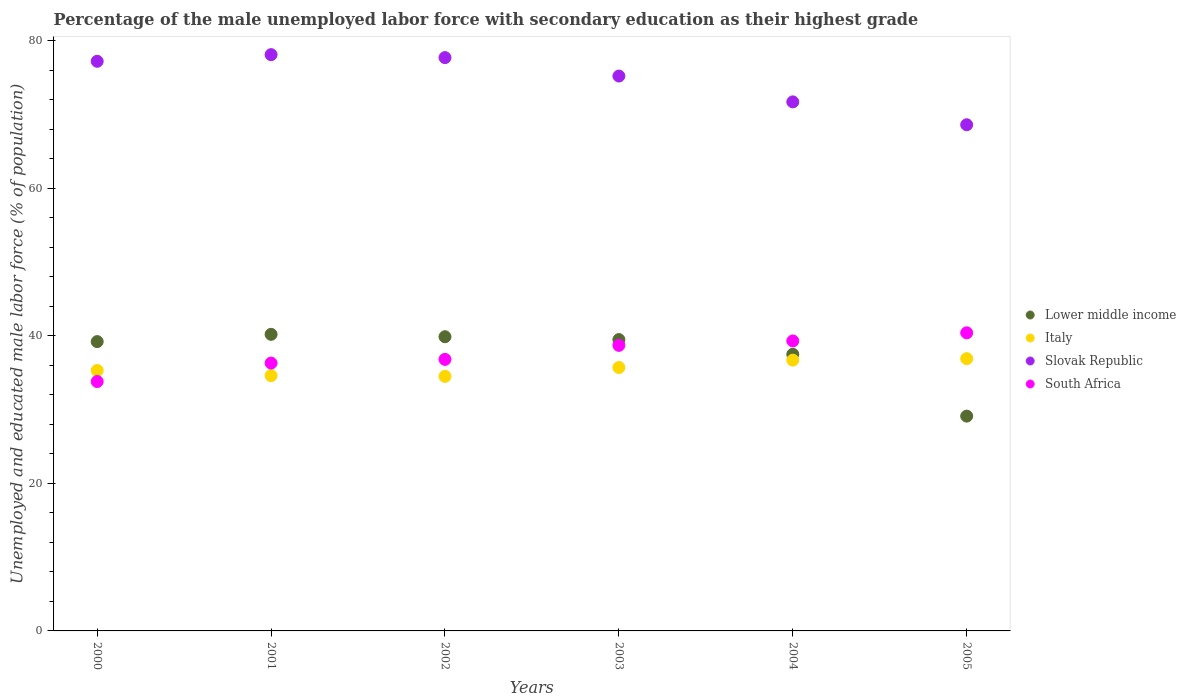How many different coloured dotlines are there?
Ensure brevity in your answer.  4. Is the number of dotlines equal to the number of legend labels?
Provide a succinct answer. Yes. What is the percentage of the unemployed male labor force with secondary education in Slovak Republic in 2002?
Offer a very short reply. 77.7. Across all years, what is the maximum percentage of the unemployed male labor force with secondary education in Slovak Republic?
Provide a short and direct response. 78.1. Across all years, what is the minimum percentage of the unemployed male labor force with secondary education in Italy?
Your response must be concise. 34.5. In which year was the percentage of the unemployed male labor force with secondary education in South Africa minimum?
Ensure brevity in your answer.  2000. What is the total percentage of the unemployed male labor force with secondary education in South Africa in the graph?
Provide a succinct answer. 225.3. What is the difference between the percentage of the unemployed male labor force with secondary education in Slovak Republic in 2004 and that in 2005?
Offer a very short reply. 3.1. What is the difference between the percentage of the unemployed male labor force with secondary education in Italy in 2004 and the percentage of the unemployed male labor force with secondary education in Slovak Republic in 2003?
Keep it short and to the point. -38.5. What is the average percentage of the unemployed male labor force with secondary education in Lower middle income per year?
Ensure brevity in your answer.  37.56. In the year 2004, what is the difference between the percentage of the unemployed male labor force with secondary education in Slovak Republic and percentage of the unemployed male labor force with secondary education in South Africa?
Ensure brevity in your answer.  32.4. What is the ratio of the percentage of the unemployed male labor force with secondary education in Italy in 2002 to that in 2003?
Offer a terse response. 0.97. Is the difference between the percentage of the unemployed male labor force with secondary education in Slovak Republic in 2002 and 2004 greater than the difference between the percentage of the unemployed male labor force with secondary education in South Africa in 2002 and 2004?
Make the answer very short. Yes. What is the difference between the highest and the second highest percentage of the unemployed male labor force with secondary education in Slovak Republic?
Offer a very short reply. 0.4. What is the difference between the highest and the lowest percentage of the unemployed male labor force with secondary education in Italy?
Offer a terse response. 2.4. In how many years, is the percentage of the unemployed male labor force with secondary education in South Africa greater than the average percentage of the unemployed male labor force with secondary education in South Africa taken over all years?
Make the answer very short. 3. Is it the case that in every year, the sum of the percentage of the unemployed male labor force with secondary education in Italy and percentage of the unemployed male labor force with secondary education in Lower middle income  is greater than the sum of percentage of the unemployed male labor force with secondary education in South Africa and percentage of the unemployed male labor force with secondary education in Slovak Republic?
Provide a succinct answer. No. Is it the case that in every year, the sum of the percentage of the unemployed male labor force with secondary education in South Africa and percentage of the unemployed male labor force with secondary education in Italy  is greater than the percentage of the unemployed male labor force with secondary education in Lower middle income?
Your answer should be compact. Yes. Is the percentage of the unemployed male labor force with secondary education in Italy strictly greater than the percentage of the unemployed male labor force with secondary education in Slovak Republic over the years?
Your response must be concise. No. Is the percentage of the unemployed male labor force with secondary education in Slovak Republic strictly less than the percentage of the unemployed male labor force with secondary education in Lower middle income over the years?
Your response must be concise. No. What is the difference between two consecutive major ticks on the Y-axis?
Give a very brief answer. 20. Are the values on the major ticks of Y-axis written in scientific E-notation?
Ensure brevity in your answer.  No. Does the graph contain grids?
Your answer should be compact. No. Where does the legend appear in the graph?
Your answer should be very brief. Center right. What is the title of the graph?
Give a very brief answer. Percentage of the male unemployed labor force with secondary education as their highest grade. What is the label or title of the Y-axis?
Ensure brevity in your answer.  Unemployed and educated male labor force (% of population). What is the Unemployed and educated male labor force (% of population) of Lower middle income in 2000?
Make the answer very short. 39.21. What is the Unemployed and educated male labor force (% of population) of Italy in 2000?
Your answer should be compact. 35.3. What is the Unemployed and educated male labor force (% of population) in Slovak Republic in 2000?
Offer a terse response. 77.2. What is the Unemployed and educated male labor force (% of population) in South Africa in 2000?
Provide a succinct answer. 33.8. What is the Unemployed and educated male labor force (% of population) in Lower middle income in 2001?
Ensure brevity in your answer.  40.19. What is the Unemployed and educated male labor force (% of population) in Italy in 2001?
Your answer should be compact. 34.6. What is the Unemployed and educated male labor force (% of population) of Slovak Republic in 2001?
Offer a very short reply. 78.1. What is the Unemployed and educated male labor force (% of population) in South Africa in 2001?
Make the answer very short. 36.3. What is the Unemployed and educated male labor force (% of population) of Lower middle income in 2002?
Provide a succinct answer. 39.87. What is the Unemployed and educated male labor force (% of population) of Italy in 2002?
Offer a terse response. 34.5. What is the Unemployed and educated male labor force (% of population) in Slovak Republic in 2002?
Ensure brevity in your answer.  77.7. What is the Unemployed and educated male labor force (% of population) of South Africa in 2002?
Offer a very short reply. 36.8. What is the Unemployed and educated male labor force (% of population) of Lower middle income in 2003?
Make the answer very short. 39.49. What is the Unemployed and educated male labor force (% of population) in Italy in 2003?
Provide a succinct answer. 35.7. What is the Unemployed and educated male labor force (% of population) of Slovak Republic in 2003?
Ensure brevity in your answer.  75.2. What is the Unemployed and educated male labor force (% of population) in South Africa in 2003?
Keep it short and to the point. 38.7. What is the Unemployed and educated male labor force (% of population) in Lower middle income in 2004?
Ensure brevity in your answer.  37.49. What is the Unemployed and educated male labor force (% of population) of Italy in 2004?
Make the answer very short. 36.7. What is the Unemployed and educated male labor force (% of population) of Slovak Republic in 2004?
Your response must be concise. 71.7. What is the Unemployed and educated male labor force (% of population) in South Africa in 2004?
Ensure brevity in your answer.  39.3. What is the Unemployed and educated male labor force (% of population) in Lower middle income in 2005?
Make the answer very short. 29.11. What is the Unemployed and educated male labor force (% of population) in Italy in 2005?
Keep it short and to the point. 36.9. What is the Unemployed and educated male labor force (% of population) of Slovak Republic in 2005?
Offer a very short reply. 68.6. What is the Unemployed and educated male labor force (% of population) in South Africa in 2005?
Provide a short and direct response. 40.4. Across all years, what is the maximum Unemployed and educated male labor force (% of population) in Lower middle income?
Offer a very short reply. 40.19. Across all years, what is the maximum Unemployed and educated male labor force (% of population) in Italy?
Your answer should be compact. 36.9. Across all years, what is the maximum Unemployed and educated male labor force (% of population) in Slovak Republic?
Your response must be concise. 78.1. Across all years, what is the maximum Unemployed and educated male labor force (% of population) in South Africa?
Ensure brevity in your answer.  40.4. Across all years, what is the minimum Unemployed and educated male labor force (% of population) in Lower middle income?
Your answer should be compact. 29.11. Across all years, what is the minimum Unemployed and educated male labor force (% of population) in Italy?
Your response must be concise. 34.5. Across all years, what is the minimum Unemployed and educated male labor force (% of population) of Slovak Republic?
Offer a very short reply. 68.6. Across all years, what is the minimum Unemployed and educated male labor force (% of population) of South Africa?
Provide a short and direct response. 33.8. What is the total Unemployed and educated male labor force (% of population) of Lower middle income in the graph?
Provide a succinct answer. 225.36. What is the total Unemployed and educated male labor force (% of population) in Italy in the graph?
Offer a very short reply. 213.7. What is the total Unemployed and educated male labor force (% of population) in Slovak Republic in the graph?
Offer a terse response. 448.5. What is the total Unemployed and educated male labor force (% of population) of South Africa in the graph?
Ensure brevity in your answer.  225.3. What is the difference between the Unemployed and educated male labor force (% of population) of Lower middle income in 2000 and that in 2001?
Your answer should be compact. -0.98. What is the difference between the Unemployed and educated male labor force (% of population) in Lower middle income in 2000 and that in 2002?
Provide a short and direct response. -0.66. What is the difference between the Unemployed and educated male labor force (% of population) in South Africa in 2000 and that in 2002?
Provide a short and direct response. -3. What is the difference between the Unemployed and educated male labor force (% of population) of Lower middle income in 2000 and that in 2003?
Provide a succinct answer. -0.28. What is the difference between the Unemployed and educated male labor force (% of population) of Italy in 2000 and that in 2003?
Your response must be concise. -0.4. What is the difference between the Unemployed and educated male labor force (% of population) of Slovak Republic in 2000 and that in 2003?
Offer a terse response. 2. What is the difference between the Unemployed and educated male labor force (% of population) in Lower middle income in 2000 and that in 2004?
Provide a short and direct response. 1.72. What is the difference between the Unemployed and educated male labor force (% of population) of South Africa in 2000 and that in 2004?
Your response must be concise. -5.5. What is the difference between the Unemployed and educated male labor force (% of population) in Lower middle income in 2000 and that in 2005?
Ensure brevity in your answer.  10.1. What is the difference between the Unemployed and educated male labor force (% of population) in Italy in 2000 and that in 2005?
Keep it short and to the point. -1.6. What is the difference between the Unemployed and educated male labor force (% of population) of South Africa in 2000 and that in 2005?
Make the answer very short. -6.6. What is the difference between the Unemployed and educated male labor force (% of population) in Lower middle income in 2001 and that in 2002?
Your answer should be compact. 0.32. What is the difference between the Unemployed and educated male labor force (% of population) of Italy in 2001 and that in 2002?
Your answer should be very brief. 0.1. What is the difference between the Unemployed and educated male labor force (% of population) in Slovak Republic in 2001 and that in 2002?
Your answer should be compact. 0.4. What is the difference between the Unemployed and educated male labor force (% of population) of South Africa in 2001 and that in 2002?
Provide a short and direct response. -0.5. What is the difference between the Unemployed and educated male labor force (% of population) of Lower middle income in 2001 and that in 2003?
Keep it short and to the point. 0.71. What is the difference between the Unemployed and educated male labor force (% of population) in Slovak Republic in 2001 and that in 2003?
Give a very brief answer. 2.9. What is the difference between the Unemployed and educated male labor force (% of population) in Lower middle income in 2001 and that in 2004?
Your answer should be very brief. 2.71. What is the difference between the Unemployed and educated male labor force (% of population) in Slovak Republic in 2001 and that in 2004?
Keep it short and to the point. 6.4. What is the difference between the Unemployed and educated male labor force (% of population) in Lower middle income in 2001 and that in 2005?
Make the answer very short. 11.08. What is the difference between the Unemployed and educated male labor force (% of population) in Slovak Republic in 2001 and that in 2005?
Keep it short and to the point. 9.5. What is the difference between the Unemployed and educated male labor force (% of population) of South Africa in 2001 and that in 2005?
Offer a very short reply. -4.1. What is the difference between the Unemployed and educated male labor force (% of population) in Lower middle income in 2002 and that in 2003?
Provide a succinct answer. 0.39. What is the difference between the Unemployed and educated male labor force (% of population) of Lower middle income in 2002 and that in 2004?
Your answer should be compact. 2.38. What is the difference between the Unemployed and educated male labor force (% of population) of Slovak Republic in 2002 and that in 2004?
Offer a terse response. 6. What is the difference between the Unemployed and educated male labor force (% of population) in Lower middle income in 2002 and that in 2005?
Make the answer very short. 10.76. What is the difference between the Unemployed and educated male labor force (% of population) in Italy in 2002 and that in 2005?
Provide a short and direct response. -2.4. What is the difference between the Unemployed and educated male labor force (% of population) of Slovak Republic in 2002 and that in 2005?
Your response must be concise. 9.1. What is the difference between the Unemployed and educated male labor force (% of population) of Lower middle income in 2003 and that in 2004?
Offer a very short reply. 2. What is the difference between the Unemployed and educated male labor force (% of population) in Lower middle income in 2003 and that in 2005?
Your answer should be very brief. 10.37. What is the difference between the Unemployed and educated male labor force (% of population) of Italy in 2003 and that in 2005?
Make the answer very short. -1.2. What is the difference between the Unemployed and educated male labor force (% of population) in Slovak Republic in 2003 and that in 2005?
Offer a terse response. 6.6. What is the difference between the Unemployed and educated male labor force (% of population) of South Africa in 2003 and that in 2005?
Provide a succinct answer. -1.7. What is the difference between the Unemployed and educated male labor force (% of population) of Lower middle income in 2004 and that in 2005?
Provide a succinct answer. 8.38. What is the difference between the Unemployed and educated male labor force (% of population) of Italy in 2004 and that in 2005?
Keep it short and to the point. -0.2. What is the difference between the Unemployed and educated male labor force (% of population) of Slovak Republic in 2004 and that in 2005?
Offer a terse response. 3.1. What is the difference between the Unemployed and educated male labor force (% of population) of Lower middle income in 2000 and the Unemployed and educated male labor force (% of population) of Italy in 2001?
Offer a terse response. 4.61. What is the difference between the Unemployed and educated male labor force (% of population) of Lower middle income in 2000 and the Unemployed and educated male labor force (% of population) of Slovak Republic in 2001?
Your answer should be very brief. -38.89. What is the difference between the Unemployed and educated male labor force (% of population) in Lower middle income in 2000 and the Unemployed and educated male labor force (% of population) in South Africa in 2001?
Your answer should be very brief. 2.91. What is the difference between the Unemployed and educated male labor force (% of population) in Italy in 2000 and the Unemployed and educated male labor force (% of population) in Slovak Republic in 2001?
Provide a succinct answer. -42.8. What is the difference between the Unemployed and educated male labor force (% of population) in Slovak Republic in 2000 and the Unemployed and educated male labor force (% of population) in South Africa in 2001?
Make the answer very short. 40.9. What is the difference between the Unemployed and educated male labor force (% of population) in Lower middle income in 2000 and the Unemployed and educated male labor force (% of population) in Italy in 2002?
Ensure brevity in your answer.  4.71. What is the difference between the Unemployed and educated male labor force (% of population) of Lower middle income in 2000 and the Unemployed and educated male labor force (% of population) of Slovak Republic in 2002?
Offer a very short reply. -38.49. What is the difference between the Unemployed and educated male labor force (% of population) of Lower middle income in 2000 and the Unemployed and educated male labor force (% of population) of South Africa in 2002?
Provide a short and direct response. 2.41. What is the difference between the Unemployed and educated male labor force (% of population) in Italy in 2000 and the Unemployed and educated male labor force (% of population) in Slovak Republic in 2002?
Provide a short and direct response. -42.4. What is the difference between the Unemployed and educated male labor force (% of population) of Slovak Republic in 2000 and the Unemployed and educated male labor force (% of population) of South Africa in 2002?
Make the answer very short. 40.4. What is the difference between the Unemployed and educated male labor force (% of population) of Lower middle income in 2000 and the Unemployed and educated male labor force (% of population) of Italy in 2003?
Provide a succinct answer. 3.51. What is the difference between the Unemployed and educated male labor force (% of population) of Lower middle income in 2000 and the Unemployed and educated male labor force (% of population) of Slovak Republic in 2003?
Offer a terse response. -35.99. What is the difference between the Unemployed and educated male labor force (% of population) in Lower middle income in 2000 and the Unemployed and educated male labor force (% of population) in South Africa in 2003?
Make the answer very short. 0.51. What is the difference between the Unemployed and educated male labor force (% of population) of Italy in 2000 and the Unemployed and educated male labor force (% of population) of Slovak Republic in 2003?
Offer a very short reply. -39.9. What is the difference between the Unemployed and educated male labor force (% of population) of Italy in 2000 and the Unemployed and educated male labor force (% of population) of South Africa in 2003?
Keep it short and to the point. -3.4. What is the difference between the Unemployed and educated male labor force (% of population) in Slovak Republic in 2000 and the Unemployed and educated male labor force (% of population) in South Africa in 2003?
Your response must be concise. 38.5. What is the difference between the Unemployed and educated male labor force (% of population) in Lower middle income in 2000 and the Unemployed and educated male labor force (% of population) in Italy in 2004?
Offer a very short reply. 2.51. What is the difference between the Unemployed and educated male labor force (% of population) of Lower middle income in 2000 and the Unemployed and educated male labor force (% of population) of Slovak Republic in 2004?
Your answer should be very brief. -32.49. What is the difference between the Unemployed and educated male labor force (% of population) of Lower middle income in 2000 and the Unemployed and educated male labor force (% of population) of South Africa in 2004?
Provide a short and direct response. -0.09. What is the difference between the Unemployed and educated male labor force (% of population) of Italy in 2000 and the Unemployed and educated male labor force (% of population) of Slovak Republic in 2004?
Your response must be concise. -36.4. What is the difference between the Unemployed and educated male labor force (% of population) in Italy in 2000 and the Unemployed and educated male labor force (% of population) in South Africa in 2004?
Keep it short and to the point. -4. What is the difference between the Unemployed and educated male labor force (% of population) in Slovak Republic in 2000 and the Unemployed and educated male labor force (% of population) in South Africa in 2004?
Provide a short and direct response. 37.9. What is the difference between the Unemployed and educated male labor force (% of population) in Lower middle income in 2000 and the Unemployed and educated male labor force (% of population) in Italy in 2005?
Make the answer very short. 2.31. What is the difference between the Unemployed and educated male labor force (% of population) of Lower middle income in 2000 and the Unemployed and educated male labor force (% of population) of Slovak Republic in 2005?
Provide a succinct answer. -29.39. What is the difference between the Unemployed and educated male labor force (% of population) of Lower middle income in 2000 and the Unemployed and educated male labor force (% of population) of South Africa in 2005?
Offer a very short reply. -1.19. What is the difference between the Unemployed and educated male labor force (% of population) of Italy in 2000 and the Unemployed and educated male labor force (% of population) of Slovak Republic in 2005?
Offer a very short reply. -33.3. What is the difference between the Unemployed and educated male labor force (% of population) in Italy in 2000 and the Unemployed and educated male labor force (% of population) in South Africa in 2005?
Offer a terse response. -5.1. What is the difference between the Unemployed and educated male labor force (% of population) in Slovak Republic in 2000 and the Unemployed and educated male labor force (% of population) in South Africa in 2005?
Your response must be concise. 36.8. What is the difference between the Unemployed and educated male labor force (% of population) of Lower middle income in 2001 and the Unemployed and educated male labor force (% of population) of Italy in 2002?
Ensure brevity in your answer.  5.69. What is the difference between the Unemployed and educated male labor force (% of population) in Lower middle income in 2001 and the Unemployed and educated male labor force (% of population) in Slovak Republic in 2002?
Your response must be concise. -37.51. What is the difference between the Unemployed and educated male labor force (% of population) of Lower middle income in 2001 and the Unemployed and educated male labor force (% of population) of South Africa in 2002?
Offer a very short reply. 3.39. What is the difference between the Unemployed and educated male labor force (% of population) of Italy in 2001 and the Unemployed and educated male labor force (% of population) of Slovak Republic in 2002?
Your response must be concise. -43.1. What is the difference between the Unemployed and educated male labor force (% of population) in Slovak Republic in 2001 and the Unemployed and educated male labor force (% of population) in South Africa in 2002?
Make the answer very short. 41.3. What is the difference between the Unemployed and educated male labor force (% of population) of Lower middle income in 2001 and the Unemployed and educated male labor force (% of population) of Italy in 2003?
Your answer should be compact. 4.49. What is the difference between the Unemployed and educated male labor force (% of population) of Lower middle income in 2001 and the Unemployed and educated male labor force (% of population) of Slovak Republic in 2003?
Offer a terse response. -35.01. What is the difference between the Unemployed and educated male labor force (% of population) of Lower middle income in 2001 and the Unemployed and educated male labor force (% of population) of South Africa in 2003?
Ensure brevity in your answer.  1.49. What is the difference between the Unemployed and educated male labor force (% of population) of Italy in 2001 and the Unemployed and educated male labor force (% of population) of Slovak Republic in 2003?
Provide a succinct answer. -40.6. What is the difference between the Unemployed and educated male labor force (% of population) of Italy in 2001 and the Unemployed and educated male labor force (% of population) of South Africa in 2003?
Provide a short and direct response. -4.1. What is the difference between the Unemployed and educated male labor force (% of population) in Slovak Republic in 2001 and the Unemployed and educated male labor force (% of population) in South Africa in 2003?
Provide a short and direct response. 39.4. What is the difference between the Unemployed and educated male labor force (% of population) in Lower middle income in 2001 and the Unemployed and educated male labor force (% of population) in Italy in 2004?
Keep it short and to the point. 3.49. What is the difference between the Unemployed and educated male labor force (% of population) of Lower middle income in 2001 and the Unemployed and educated male labor force (% of population) of Slovak Republic in 2004?
Your answer should be compact. -31.51. What is the difference between the Unemployed and educated male labor force (% of population) in Lower middle income in 2001 and the Unemployed and educated male labor force (% of population) in South Africa in 2004?
Ensure brevity in your answer.  0.89. What is the difference between the Unemployed and educated male labor force (% of population) of Italy in 2001 and the Unemployed and educated male labor force (% of population) of Slovak Republic in 2004?
Ensure brevity in your answer.  -37.1. What is the difference between the Unemployed and educated male labor force (% of population) in Italy in 2001 and the Unemployed and educated male labor force (% of population) in South Africa in 2004?
Your answer should be compact. -4.7. What is the difference between the Unemployed and educated male labor force (% of population) in Slovak Republic in 2001 and the Unemployed and educated male labor force (% of population) in South Africa in 2004?
Your answer should be compact. 38.8. What is the difference between the Unemployed and educated male labor force (% of population) of Lower middle income in 2001 and the Unemployed and educated male labor force (% of population) of Italy in 2005?
Offer a terse response. 3.29. What is the difference between the Unemployed and educated male labor force (% of population) of Lower middle income in 2001 and the Unemployed and educated male labor force (% of population) of Slovak Republic in 2005?
Provide a short and direct response. -28.41. What is the difference between the Unemployed and educated male labor force (% of population) of Lower middle income in 2001 and the Unemployed and educated male labor force (% of population) of South Africa in 2005?
Your answer should be very brief. -0.21. What is the difference between the Unemployed and educated male labor force (% of population) in Italy in 2001 and the Unemployed and educated male labor force (% of population) in Slovak Republic in 2005?
Your answer should be very brief. -34. What is the difference between the Unemployed and educated male labor force (% of population) in Slovak Republic in 2001 and the Unemployed and educated male labor force (% of population) in South Africa in 2005?
Your answer should be very brief. 37.7. What is the difference between the Unemployed and educated male labor force (% of population) of Lower middle income in 2002 and the Unemployed and educated male labor force (% of population) of Italy in 2003?
Provide a succinct answer. 4.17. What is the difference between the Unemployed and educated male labor force (% of population) in Lower middle income in 2002 and the Unemployed and educated male labor force (% of population) in Slovak Republic in 2003?
Your response must be concise. -35.33. What is the difference between the Unemployed and educated male labor force (% of population) in Lower middle income in 2002 and the Unemployed and educated male labor force (% of population) in South Africa in 2003?
Make the answer very short. 1.17. What is the difference between the Unemployed and educated male labor force (% of population) of Italy in 2002 and the Unemployed and educated male labor force (% of population) of Slovak Republic in 2003?
Offer a terse response. -40.7. What is the difference between the Unemployed and educated male labor force (% of population) in Italy in 2002 and the Unemployed and educated male labor force (% of population) in South Africa in 2003?
Provide a succinct answer. -4.2. What is the difference between the Unemployed and educated male labor force (% of population) of Slovak Republic in 2002 and the Unemployed and educated male labor force (% of population) of South Africa in 2003?
Make the answer very short. 39. What is the difference between the Unemployed and educated male labor force (% of population) of Lower middle income in 2002 and the Unemployed and educated male labor force (% of population) of Italy in 2004?
Ensure brevity in your answer.  3.17. What is the difference between the Unemployed and educated male labor force (% of population) in Lower middle income in 2002 and the Unemployed and educated male labor force (% of population) in Slovak Republic in 2004?
Keep it short and to the point. -31.83. What is the difference between the Unemployed and educated male labor force (% of population) in Lower middle income in 2002 and the Unemployed and educated male labor force (% of population) in South Africa in 2004?
Your response must be concise. 0.57. What is the difference between the Unemployed and educated male labor force (% of population) in Italy in 2002 and the Unemployed and educated male labor force (% of population) in Slovak Republic in 2004?
Your answer should be compact. -37.2. What is the difference between the Unemployed and educated male labor force (% of population) of Slovak Republic in 2002 and the Unemployed and educated male labor force (% of population) of South Africa in 2004?
Offer a very short reply. 38.4. What is the difference between the Unemployed and educated male labor force (% of population) of Lower middle income in 2002 and the Unemployed and educated male labor force (% of population) of Italy in 2005?
Make the answer very short. 2.97. What is the difference between the Unemployed and educated male labor force (% of population) in Lower middle income in 2002 and the Unemployed and educated male labor force (% of population) in Slovak Republic in 2005?
Give a very brief answer. -28.73. What is the difference between the Unemployed and educated male labor force (% of population) of Lower middle income in 2002 and the Unemployed and educated male labor force (% of population) of South Africa in 2005?
Offer a terse response. -0.53. What is the difference between the Unemployed and educated male labor force (% of population) of Italy in 2002 and the Unemployed and educated male labor force (% of population) of Slovak Republic in 2005?
Keep it short and to the point. -34.1. What is the difference between the Unemployed and educated male labor force (% of population) in Italy in 2002 and the Unemployed and educated male labor force (% of population) in South Africa in 2005?
Your answer should be very brief. -5.9. What is the difference between the Unemployed and educated male labor force (% of population) in Slovak Republic in 2002 and the Unemployed and educated male labor force (% of population) in South Africa in 2005?
Keep it short and to the point. 37.3. What is the difference between the Unemployed and educated male labor force (% of population) of Lower middle income in 2003 and the Unemployed and educated male labor force (% of population) of Italy in 2004?
Your answer should be very brief. 2.79. What is the difference between the Unemployed and educated male labor force (% of population) of Lower middle income in 2003 and the Unemployed and educated male labor force (% of population) of Slovak Republic in 2004?
Ensure brevity in your answer.  -32.22. What is the difference between the Unemployed and educated male labor force (% of population) of Lower middle income in 2003 and the Unemployed and educated male labor force (% of population) of South Africa in 2004?
Offer a terse response. 0.18. What is the difference between the Unemployed and educated male labor force (% of population) in Italy in 2003 and the Unemployed and educated male labor force (% of population) in Slovak Republic in 2004?
Provide a succinct answer. -36. What is the difference between the Unemployed and educated male labor force (% of population) in Slovak Republic in 2003 and the Unemployed and educated male labor force (% of population) in South Africa in 2004?
Provide a succinct answer. 35.9. What is the difference between the Unemployed and educated male labor force (% of population) in Lower middle income in 2003 and the Unemployed and educated male labor force (% of population) in Italy in 2005?
Offer a very short reply. 2.58. What is the difference between the Unemployed and educated male labor force (% of population) of Lower middle income in 2003 and the Unemployed and educated male labor force (% of population) of Slovak Republic in 2005?
Your answer should be very brief. -29.11. What is the difference between the Unemployed and educated male labor force (% of population) of Lower middle income in 2003 and the Unemployed and educated male labor force (% of population) of South Africa in 2005?
Offer a very short reply. -0.92. What is the difference between the Unemployed and educated male labor force (% of population) in Italy in 2003 and the Unemployed and educated male labor force (% of population) in Slovak Republic in 2005?
Keep it short and to the point. -32.9. What is the difference between the Unemployed and educated male labor force (% of population) in Slovak Republic in 2003 and the Unemployed and educated male labor force (% of population) in South Africa in 2005?
Provide a short and direct response. 34.8. What is the difference between the Unemployed and educated male labor force (% of population) in Lower middle income in 2004 and the Unemployed and educated male labor force (% of population) in Italy in 2005?
Your answer should be very brief. 0.59. What is the difference between the Unemployed and educated male labor force (% of population) of Lower middle income in 2004 and the Unemployed and educated male labor force (% of population) of Slovak Republic in 2005?
Keep it short and to the point. -31.11. What is the difference between the Unemployed and educated male labor force (% of population) of Lower middle income in 2004 and the Unemployed and educated male labor force (% of population) of South Africa in 2005?
Offer a terse response. -2.91. What is the difference between the Unemployed and educated male labor force (% of population) of Italy in 2004 and the Unemployed and educated male labor force (% of population) of Slovak Republic in 2005?
Give a very brief answer. -31.9. What is the difference between the Unemployed and educated male labor force (% of population) of Slovak Republic in 2004 and the Unemployed and educated male labor force (% of population) of South Africa in 2005?
Your answer should be very brief. 31.3. What is the average Unemployed and educated male labor force (% of population) in Lower middle income per year?
Provide a succinct answer. 37.56. What is the average Unemployed and educated male labor force (% of population) in Italy per year?
Offer a very short reply. 35.62. What is the average Unemployed and educated male labor force (% of population) in Slovak Republic per year?
Offer a terse response. 74.75. What is the average Unemployed and educated male labor force (% of population) in South Africa per year?
Offer a very short reply. 37.55. In the year 2000, what is the difference between the Unemployed and educated male labor force (% of population) in Lower middle income and Unemployed and educated male labor force (% of population) in Italy?
Your answer should be very brief. 3.91. In the year 2000, what is the difference between the Unemployed and educated male labor force (% of population) in Lower middle income and Unemployed and educated male labor force (% of population) in Slovak Republic?
Keep it short and to the point. -37.99. In the year 2000, what is the difference between the Unemployed and educated male labor force (% of population) in Lower middle income and Unemployed and educated male labor force (% of population) in South Africa?
Your answer should be very brief. 5.41. In the year 2000, what is the difference between the Unemployed and educated male labor force (% of population) in Italy and Unemployed and educated male labor force (% of population) in Slovak Republic?
Offer a terse response. -41.9. In the year 2000, what is the difference between the Unemployed and educated male labor force (% of population) of Italy and Unemployed and educated male labor force (% of population) of South Africa?
Your answer should be very brief. 1.5. In the year 2000, what is the difference between the Unemployed and educated male labor force (% of population) of Slovak Republic and Unemployed and educated male labor force (% of population) of South Africa?
Provide a succinct answer. 43.4. In the year 2001, what is the difference between the Unemployed and educated male labor force (% of population) of Lower middle income and Unemployed and educated male labor force (% of population) of Italy?
Keep it short and to the point. 5.59. In the year 2001, what is the difference between the Unemployed and educated male labor force (% of population) in Lower middle income and Unemployed and educated male labor force (% of population) in Slovak Republic?
Offer a very short reply. -37.91. In the year 2001, what is the difference between the Unemployed and educated male labor force (% of population) of Lower middle income and Unemployed and educated male labor force (% of population) of South Africa?
Make the answer very short. 3.89. In the year 2001, what is the difference between the Unemployed and educated male labor force (% of population) of Italy and Unemployed and educated male labor force (% of population) of Slovak Republic?
Your response must be concise. -43.5. In the year 2001, what is the difference between the Unemployed and educated male labor force (% of population) of Italy and Unemployed and educated male labor force (% of population) of South Africa?
Provide a short and direct response. -1.7. In the year 2001, what is the difference between the Unemployed and educated male labor force (% of population) of Slovak Republic and Unemployed and educated male labor force (% of population) of South Africa?
Your response must be concise. 41.8. In the year 2002, what is the difference between the Unemployed and educated male labor force (% of population) of Lower middle income and Unemployed and educated male labor force (% of population) of Italy?
Your response must be concise. 5.37. In the year 2002, what is the difference between the Unemployed and educated male labor force (% of population) in Lower middle income and Unemployed and educated male labor force (% of population) in Slovak Republic?
Provide a short and direct response. -37.83. In the year 2002, what is the difference between the Unemployed and educated male labor force (% of population) in Lower middle income and Unemployed and educated male labor force (% of population) in South Africa?
Provide a short and direct response. 3.07. In the year 2002, what is the difference between the Unemployed and educated male labor force (% of population) of Italy and Unemployed and educated male labor force (% of population) of Slovak Republic?
Make the answer very short. -43.2. In the year 2002, what is the difference between the Unemployed and educated male labor force (% of population) of Italy and Unemployed and educated male labor force (% of population) of South Africa?
Ensure brevity in your answer.  -2.3. In the year 2002, what is the difference between the Unemployed and educated male labor force (% of population) in Slovak Republic and Unemployed and educated male labor force (% of population) in South Africa?
Give a very brief answer. 40.9. In the year 2003, what is the difference between the Unemployed and educated male labor force (% of population) of Lower middle income and Unemployed and educated male labor force (% of population) of Italy?
Offer a very short reply. 3.79. In the year 2003, what is the difference between the Unemployed and educated male labor force (% of population) of Lower middle income and Unemployed and educated male labor force (% of population) of Slovak Republic?
Provide a succinct answer. -35.72. In the year 2003, what is the difference between the Unemployed and educated male labor force (% of population) of Lower middle income and Unemployed and educated male labor force (% of population) of South Africa?
Offer a terse response. 0.79. In the year 2003, what is the difference between the Unemployed and educated male labor force (% of population) of Italy and Unemployed and educated male labor force (% of population) of Slovak Republic?
Ensure brevity in your answer.  -39.5. In the year 2003, what is the difference between the Unemployed and educated male labor force (% of population) of Italy and Unemployed and educated male labor force (% of population) of South Africa?
Offer a terse response. -3. In the year 2003, what is the difference between the Unemployed and educated male labor force (% of population) of Slovak Republic and Unemployed and educated male labor force (% of population) of South Africa?
Make the answer very short. 36.5. In the year 2004, what is the difference between the Unemployed and educated male labor force (% of population) in Lower middle income and Unemployed and educated male labor force (% of population) in Italy?
Make the answer very short. 0.79. In the year 2004, what is the difference between the Unemployed and educated male labor force (% of population) in Lower middle income and Unemployed and educated male labor force (% of population) in Slovak Republic?
Your answer should be compact. -34.21. In the year 2004, what is the difference between the Unemployed and educated male labor force (% of population) of Lower middle income and Unemployed and educated male labor force (% of population) of South Africa?
Your answer should be compact. -1.81. In the year 2004, what is the difference between the Unemployed and educated male labor force (% of population) in Italy and Unemployed and educated male labor force (% of population) in Slovak Republic?
Provide a succinct answer. -35. In the year 2004, what is the difference between the Unemployed and educated male labor force (% of population) in Slovak Republic and Unemployed and educated male labor force (% of population) in South Africa?
Make the answer very short. 32.4. In the year 2005, what is the difference between the Unemployed and educated male labor force (% of population) in Lower middle income and Unemployed and educated male labor force (% of population) in Italy?
Make the answer very short. -7.79. In the year 2005, what is the difference between the Unemployed and educated male labor force (% of population) of Lower middle income and Unemployed and educated male labor force (% of population) of Slovak Republic?
Give a very brief answer. -39.49. In the year 2005, what is the difference between the Unemployed and educated male labor force (% of population) in Lower middle income and Unemployed and educated male labor force (% of population) in South Africa?
Provide a short and direct response. -11.29. In the year 2005, what is the difference between the Unemployed and educated male labor force (% of population) of Italy and Unemployed and educated male labor force (% of population) of Slovak Republic?
Make the answer very short. -31.7. In the year 2005, what is the difference between the Unemployed and educated male labor force (% of population) of Slovak Republic and Unemployed and educated male labor force (% of population) of South Africa?
Ensure brevity in your answer.  28.2. What is the ratio of the Unemployed and educated male labor force (% of population) in Lower middle income in 2000 to that in 2001?
Provide a succinct answer. 0.98. What is the ratio of the Unemployed and educated male labor force (% of population) in Italy in 2000 to that in 2001?
Your answer should be very brief. 1.02. What is the ratio of the Unemployed and educated male labor force (% of population) of Slovak Republic in 2000 to that in 2001?
Provide a short and direct response. 0.99. What is the ratio of the Unemployed and educated male labor force (% of population) in South Africa in 2000 to that in 2001?
Keep it short and to the point. 0.93. What is the ratio of the Unemployed and educated male labor force (% of population) in Lower middle income in 2000 to that in 2002?
Your response must be concise. 0.98. What is the ratio of the Unemployed and educated male labor force (% of population) in Italy in 2000 to that in 2002?
Provide a succinct answer. 1.02. What is the ratio of the Unemployed and educated male labor force (% of population) in South Africa in 2000 to that in 2002?
Keep it short and to the point. 0.92. What is the ratio of the Unemployed and educated male labor force (% of population) in Slovak Republic in 2000 to that in 2003?
Your response must be concise. 1.03. What is the ratio of the Unemployed and educated male labor force (% of population) of South Africa in 2000 to that in 2003?
Give a very brief answer. 0.87. What is the ratio of the Unemployed and educated male labor force (% of population) in Lower middle income in 2000 to that in 2004?
Your response must be concise. 1.05. What is the ratio of the Unemployed and educated male labor force (% of population) of Italy in 2000 to that in 2004?
Make the answer very short. 0.96. What is the ratio of the Unemployed and educated male labor force (% of population) of Slovak Republic in 2000 to that in 2004?
Offer a very short reply. 1.08. What is the ratio of the Unemployed and educated male labor force (% of population) of South Africa in 2000 to that in 2004?
Your response must be concise. 0.86. What is the ratio of the Unemployed and educated male labor force (% of population) in Lower middle income in 2000 to that in 2005?
Offer a terse response. 1.35. What is the ratio of the Unemployed and educated male labor force (% of population) in Italy in 2000 to that in 2005?
Provide a succinct answer. 0.96. What is the ratio of the Unemployed and educated male labor force (% of population) in Slovak Republic in 2000 to that in 2005?
Make the answer very short. 1.13. What is the ratio of the Unemployed and educated male labor force (% of population) of South Africa in 2000 to that in 2005?
Your answer should be very brief. 0.84. What is the ratio of the Unemployed and educated male labor force (% of population) of Italy in 2001 to that in 2002?
Offer a very short reply. 1. What is the ratio of the Unemployed and educated male labor force (% of population) of Slovak Republic in 2001 to that in 2002?
Ensure brevity in your answer.  1.01. What is the ratio of the Unemployed and educated male labor force (% of population) of South Africa in 2001 to that in 2002?
Provide a short and direct response. 0.99. What is the ratio of the Unemployed and educated male labor force (% of population) in Italy in 2001 to that in 2003?
Provide a succinct answer. 0.97. What is the ratio of the Unemployed and educated male labor force (% of population) in Slovak Republic in 2001 to that in 2003?
Give a very brief answer. 1.04. What is the ratio of the Unemployed and educated male labor force (% of population) in South Africa in 2001 to that in 2003?
Provide a succinct answer. 0.94. What is the ratio of the Unemployed and educated male labor force (% of population) in Lower middle income in 2001 to that in 2004?
Keep it short and to the point. 1.07. What is the ratio of the Unemployed and educated male labor force (% of population) in Italy in 2001 to that in 2004?
Offer a terse response. 0.94. What is the ratio of the Unemployed and educated male labor force (% of population) of Slovak Republic in 2001 to that in 2004?
Keep it short and to the point. 1.09. What is the ratio of the Unemployed and educated male labor force (% of population) in South Africa in 2001 to that in 2004?
Provide a succinct answer. 0.92. What is the ratio of the Unemployed and educated male labor force (% of population) of Lower middle income in 2001 to that in 2005?
Your response must be concise. 1.38. What is the ratio of the Unemployed and educated male labor force (% of population) of Italy in 2001 to that in 2005?
Offer a very short reply. 0.94. What is the ratio of the Unemployed and educated male labor force (% of population) of Slovak Republic in 2001 to that in 2005?
Offer a terse response. 1.14. What is the ratio of the Unemployed and educated male labor force (% of population) of South Africa in 2001 to that in 2005?
Offer a terse response. 0.9. What is the ratio of the Unemployed and educated male labor force (% of population) of Lower middle income in 2002 to that in 2003?
Your answer should be very brief. 1.01. What is the ratio of the Unemployed and educated male labor force (% of population) in Italy in 2002 to that in 2003?
Your response must be concise. 0.97. What is the ratio of the Unemployed and educated male labor force (% of population) in Slovak Republic in 2002 to that in 2003?
Offer a very short reply. 1.03. What is the ratio of the Unemployed and educated male labor force (% of population) in South Africa in 2002 to that in 2003?
Offer a very short reply. 0.95. What is the ratio of the Unemployed and educated male labor force (% of population) in Lower middle income in 2002 to that in 2004?
Make the answer very short. 1.06. What is the ratio of the Unemployed and educated male labor force (% of population) in Italy in 2002 to that in 2004?
Keep it short and to the point. 0.94. What is the ratio of the Unemployed and educated male labor force (% of population) of Slovak Republic in 2002 to that in 2004?
Offer a very short reply. 1.08. What is the ratio of the Unemployed and educated male labor force (% of population) in South Africa in 2002 to that in 2004?
Offer a very short reply. 0.94. What is the ratio of the Unemployed and educated male labor force (% of population) of Lower middle income in 2002 to that in 2005?
Keep it short and to the point. 1.37. What is the ratio of the Unemployed and educated male labor force (% of population) in Italy in 2002 to that in 2005?
Give a very brief answer. 0.94. What is the ratio of the Unemployed and educated male labor force (% of population) of Slovak Republic in 2002 to that in 2005?
Give a very brief answer. 1.13. What is the ratio of the Unemployed and educated male labor force (% of population) of South Africa in 2002 to that in 2005?
Make the answer very short. 0.91. What is the ratio of the Unemployed and educated male labor force (% of population) of Lower middle income in 2003 to that in 2004?
Your response must be concise. 1.05. What is the ratio of the Unemployed and educated male labor force (% of population) of Italy in 2003 to that in 2004?
Your response must be concise. 0.97. What is the ratio of the Unemployed and educated male labor force (% of population) of Slovak Republic in 2003 to that in 2004?
Ensure brevity in your answer.  1.05. What is the ratio of the Unemployed and educated male labor force (% of population) of South Africa in 2003 to that in 2004?
Offer a terse response. 0.98. What is the ratio of the Unemployed and educated male labor force (% of population) in Lower middle income in 2003 to that in 2005?
Your response must be concise. 1.36. What is the ratio of the Unemployed and educated male labor force (% of population) of Italy in 2003 to that in 2005?
Make the answer very short. 0.97. What is the ratio of the Unemployed and educated male labor force (% of population) of Slovak Republic in 2003 to that in 2005?
Give a very brief answer. 1.1. What is the ratio of the Unemployed and educated male labor force (% of population) of South Africa in 2003 to that in 2005?
Your answer should be very brief. 0.96. What is the ratio of the Unemployed and educated male labor force (% of population) in Lower middle income in 2004 to that in 2005?
Provide a succinct answer. 1.29. What is the ratio of the Unemployed and educated male labor force (% of population) of Slovak Republic in 2004 to that in 2005?
Provide a succinct answer. 1.05. What is the ratio of the Unemployed and educated male labor force (% of population) of South Africa in 2004 to that in 2005?
Ensure brevity in your answer.  0.97. What is the difference between the highest and the second highest Unemployed and educated male labor force (% of population) of Lower middle income?
Provide a short and direct response. 0.32. What is the difference between the highest and the second highest Unemployed and educated male labor force (% of population) in South Africa?
Provide a short and direct response. 1.1. What is the difference between the highest and the lowest Unemployed and educated male labor force (% of population) in Lower middle income?
Give a very brief answer. 11.08. What is the difference between the highest and the lowest Unemployed and educated male labor force (% of population) in South Africa?
Make the answer very short. 6.6. 